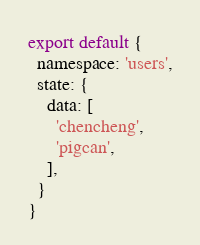Convert code to text. <code><loc_0><loc_0><loc_500><loc_500><_JavaScript_>
export default {
  namespace: 'users',
  state: {
    data: [
      'chencheng',
      'pigcan',
    ],
  }
}
</code> 